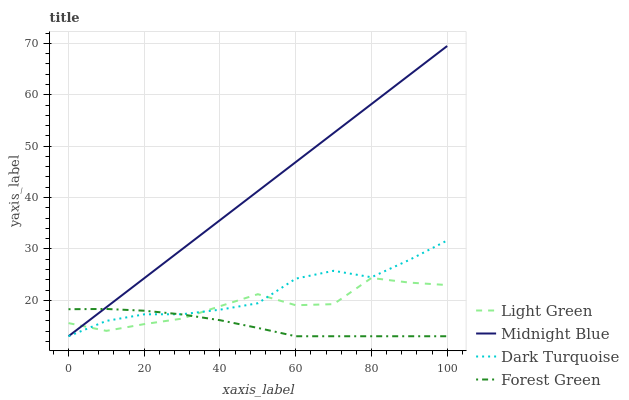Does Forest Green have the minimum area under the curve?
Answer yes or no. Yes. Does Midnight Blue have the maximum area under the curve?
Answer yes or no. Yes. Does Midnight Blue have the minimum area under the curve?
Answer yes or no. No. Does Forest Green have the maximum area under the curve?
Answer yes or no. No. Is Midnight Blue the smoothest?
Answer yes or no. Yes. Is Light Green the roughest?
Answer yes or no. Yes. Is Forest Green the smoothest?
Answer yes or no. No. Is Forest Green the roughest?
Answer yes or no. No. Does Dark Turquoise have the lowest value?
Answer yes or no. Yes. Does Light Green have the lowest value?
Answer yes or no. No. Does Midnight Blue have the highest value?
Answer yes or no. Yes. Does Forest Green have the highest value?
Answer yes or no. No. Does Dark Turquoise intersect Light Green?
Answer yes or no. Yes. Is Dark Turquoise less than Light Green?
Answer yes or no. No. Is Dark Turquoise greater than Light Green?
Answer yes or no. No. 